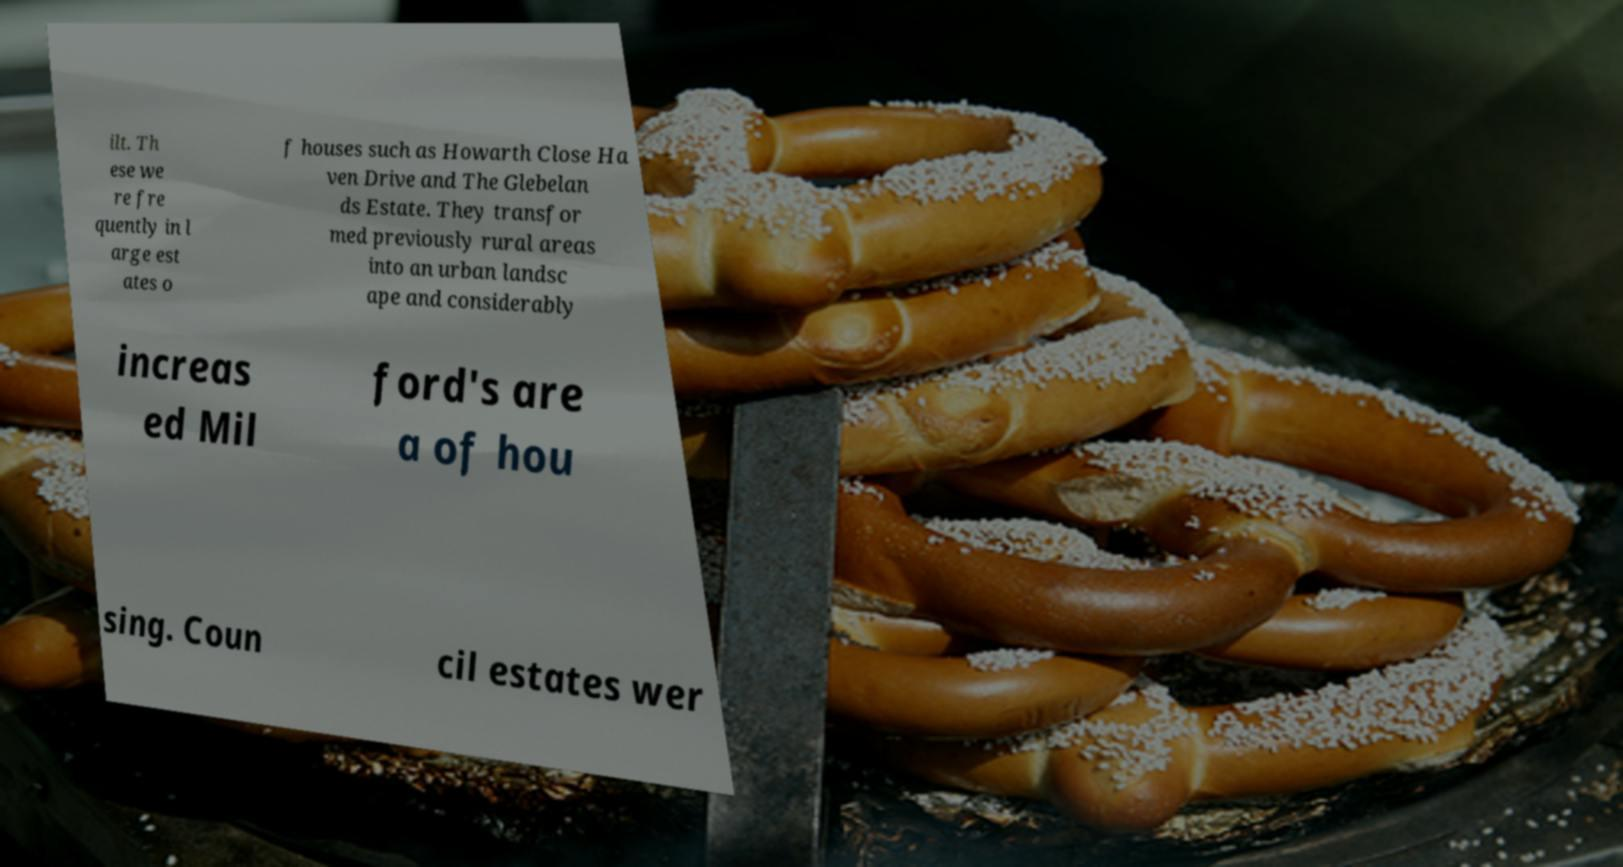Can you accurately transcribe the text from the provided image for me? ilt. Th ese we re fre quently in l arge est ates o f houses such as Howarth Close Ha ven Drive and The Glebelan ds Estate. They transfor med previously rural areas into an urban landsc ape and considerably increas ed Mil ford's are a of hou sing. Coun cil estates wer 